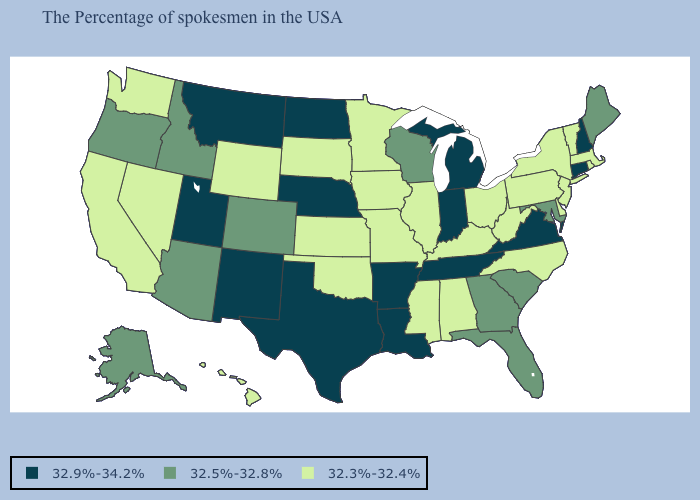What is the lowest value in the USA?
Short answer required. 32.3%-32.4%. Does Oklahoma have a lower value than Ohio?
Short answer required. No. Name the states that have a value in the range 32.3%-32.4%?
Quick response, please. Massachusetts, Rhode Island, Vermont, New York, New Jersey, Delaware, Pennsylvania, North Carolina, West Virginia, Ohio, Kentucky, Alabama, Illinois, Mississippi, Missouri, Minnesota, Iowa, Kansas, Oklahoma, South Dakota, Wyoming, Nevada, California, Washington, Hawaii. What is the value of Wyoming?
Concise answer only. 32.3%-32.4%. Does Massachusetts have a lower value than West Virginia?
Keep it brief. No. Does the first symbol in the legend represent the smallest category?
Give a very brief answer. No. What is the value of Utah?
Concise answer only. 32.9%-34.2%. What is the value of California?
Be succinct. 32.3%-32.4%. Name the states that have a value in the range 32.3%-32.4%?
Be succinct. Massachusetts, Rhode Island, Vermont, New York, New Jersey, Delaware, Pennsylvania, North Carolina, West Virginia, Ohio, Kentucky, Alabama, Illinois, Mississippi, Missouri, Minnesota, Iowa, Kansas, Oklahoma, South Dakota, Wyoming, Nevada, California, Washington, Hawaii. What is the value of Utah?
Answer briefly. 32.9%-34.2%. How many symbols are there in the legend?
Short answer required. 3. What is the value of North Carolina?
Short answer required. 32.3%-32.4%. Which states hav the highest value in the South?
Give a very brief answer. Virginia, Tennessee, Louisiana, Arkansas, Texas. Name the states that have a value in the range 32.5%-32.8%?
Be succinct. Maine, Maryland, South Carolina, Florida, Georgia, Wisconsin, Colorado, Arizona, Idaho, Oregon, Alaska. Name the states that have a value in the range 32.3%-32.4%?
Short answer required. Massachusetts, Rhode Island, Vermont, New York, New Jersey, Delaware, Pennsylvania, North Carolina, West Virginia, Ohio, Kentucky, Alabama, Illinois, Mississippi, Missouri, Minnesota, Iowa, Kansas, Oklahoma, South Dakota, Wyoming, Nevada, California, Washington, Hawaii. 